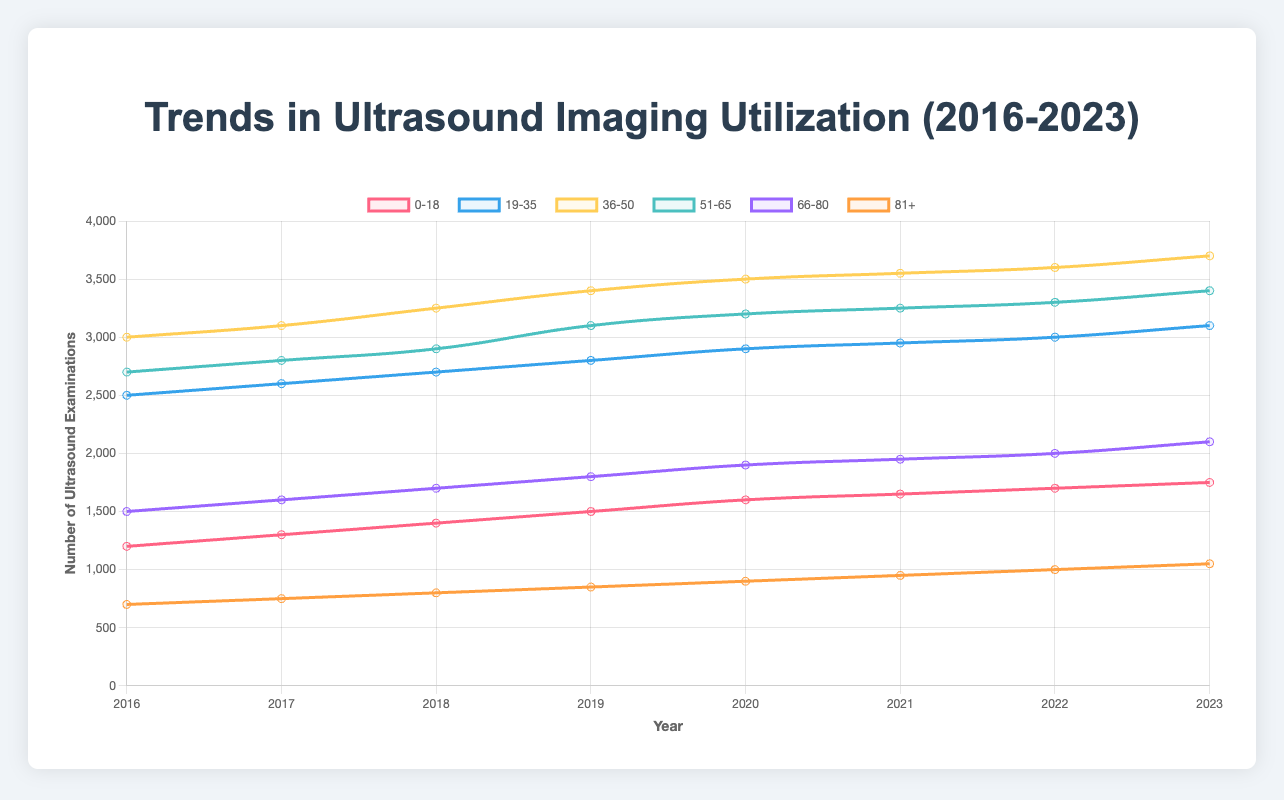Which age group showed the highest utilization of ultrasound imaging in 2023? Look at the data points in the year 2023 for each age group and identify the highest value. The age group "36-50" has the highest value of 3700.
Answer: 36-50 How did the utilization for the age group "51-65" change from 2016 to 2023? Check the values for "51-65" in the years 2016 and 2023. The utilization increased from 2700 to 3400. The difference is 3400 - 2700 = 700, thus showing an increase.
Answer: Increased by 700 Which year had the largest increase in ultrasound imaging utilization for the age group "0-18"? Compare the yearly changes in the "0-18" values. From 2016 to 2017, the difference is 1300 - 1200 = 100. From 2017 to 2018, the difference is 1400 - 1300 = 100. From 2018 to 2019, the difference is 1500 - 1400 = 100. From 2019 to 2020, the difference is 1600 - 1500 = 100. From 2020 to 2021, the difference is 1650 - 1600 = 50. From 2021 to 2022, the difference is 1700 - 1650 = 50. From 2022 to 2023, the difference is 1750 - 1700 = 50. The years with the largest increase are 2016 to 2017, 2017 to 2018, 2018 to 2019, and 2019 to 2020 with an increase of 100 each.
Answer: 2016-2017, 2017-2018, 2018-2019, 2019-2020 Between the years 2021 and 2023, which age group showed the smallest absolute increase in utilization? Calculate the difference in utilization for each age group between 2021 and 2023. The differences are as follows: "0-18": 1750 - 1650 = 100, "19-35": 3100 - 2950 = 150, "36-50": 3700 - 3550 = 150, "51-65": 3400 - 3250 = 150, "66-80": 2100 - 1950 = 150, "81+": 1050 - 950 = 100. The smallest increase is in the age groups "0-18" and "81+" with an increase of 100 each.
Answer: 0-18, 81+ What is the trend in ultrasound imaging utilization for the age group "19-35" over the years? Observe the values for the age group "19-35" from 2016 to 2023: (2016: 2500, 2017: 2600, 2018: 2700, 2019: 2800, 2020: 2900, 2021: 2950, 2022: 3000, 2023: 3100). The values increase every year indicating a consistent upward trend in utilization.
Answer: Upward trend What was the average utilization of ultrasound imaging across all age groups in the year 2020? Sum the utilization values for all age groups in 2020 and divide by the number of age groups. The sum is (1600 + 2900 + 3500 + 3200 + 1900 + 900) = 14000. There are 6 age groups, so the average is 14000 / 6 = 2333.33
Answer: 2333.33 Which age group has the steadiest increase in utilization from 2016 to 2023? Compare the yearly increments for each age group. The "0-18" group increases by 100-150 each year; "19-35" increases by 100-200 each year; "36-50" increases by 100-250; "51-65" increases by 100-300; "66-80" increases by 100 each year; "81+" increases by 50-100. The "66-80" age group shows the most steady increment, with a consistent increase of 100 each year.
Answer: 66-80 